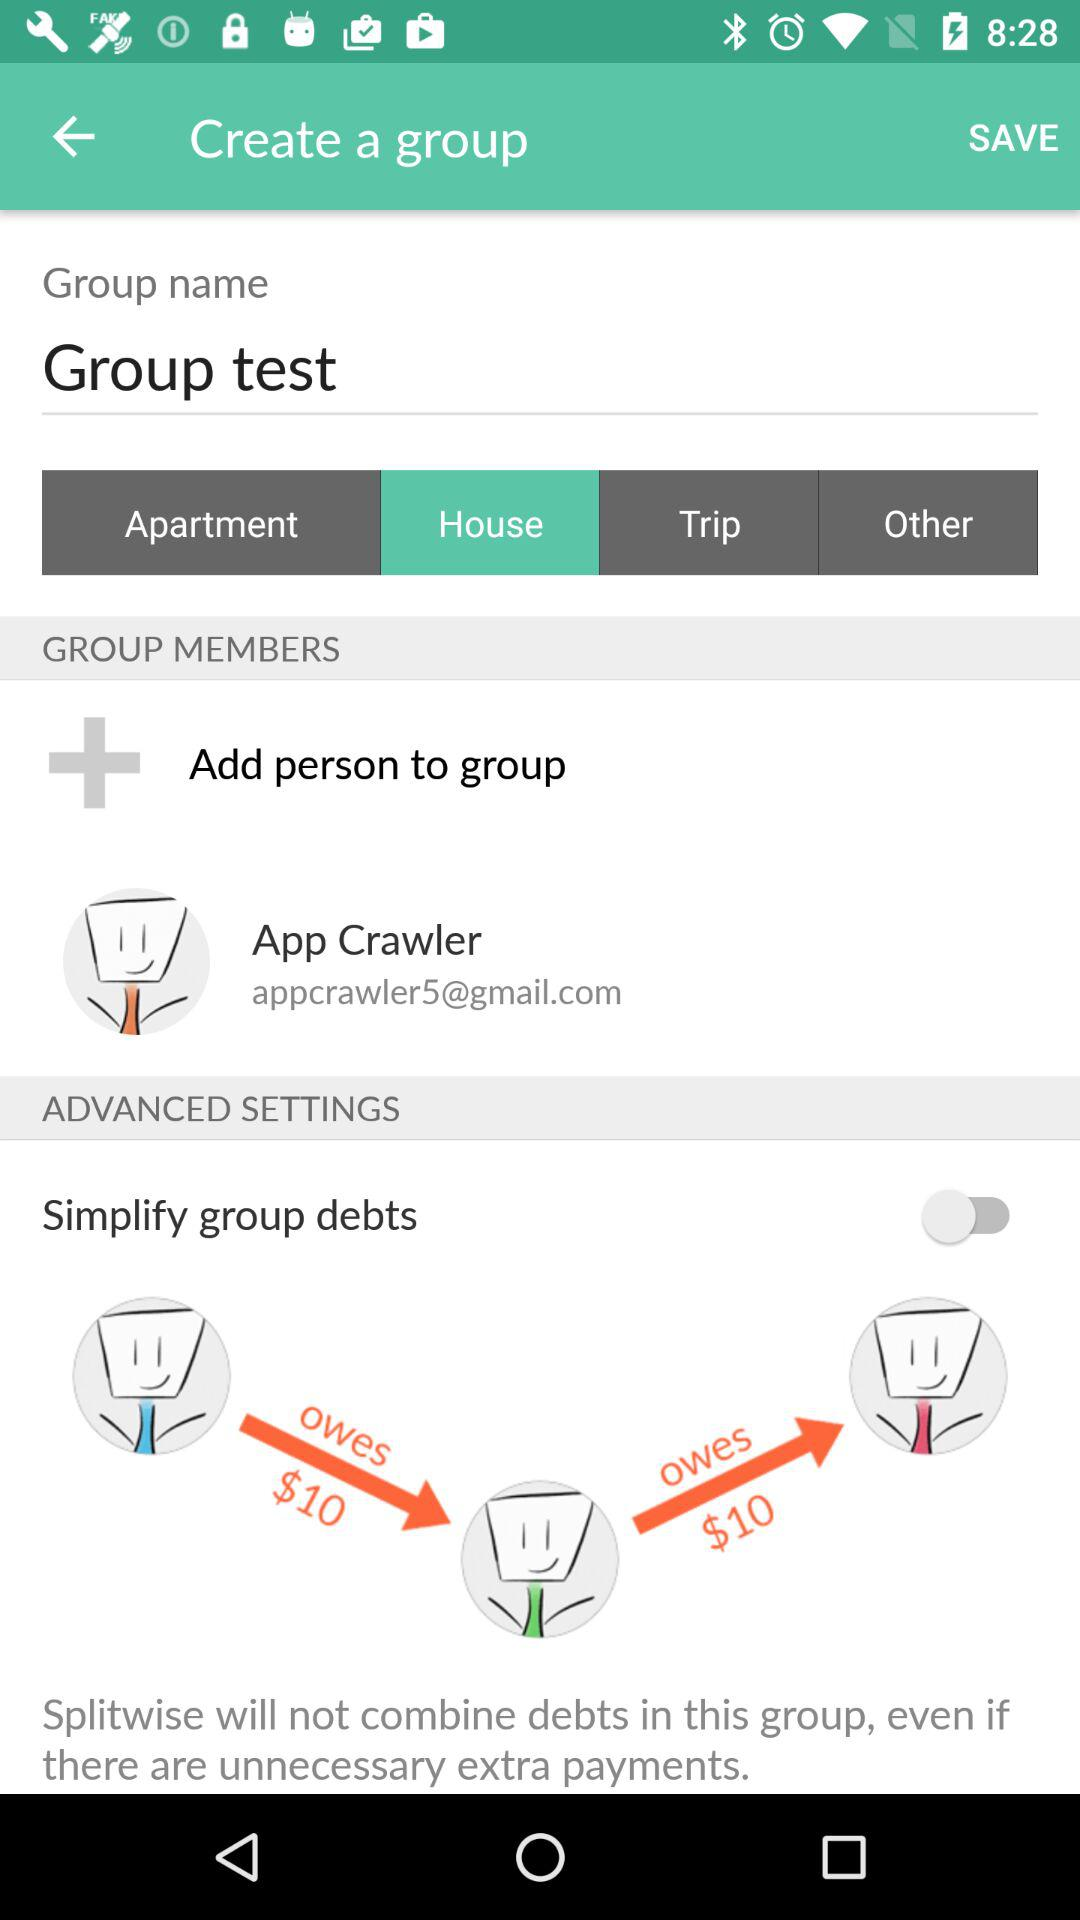Who is the group member? The group member is App Crawler. 